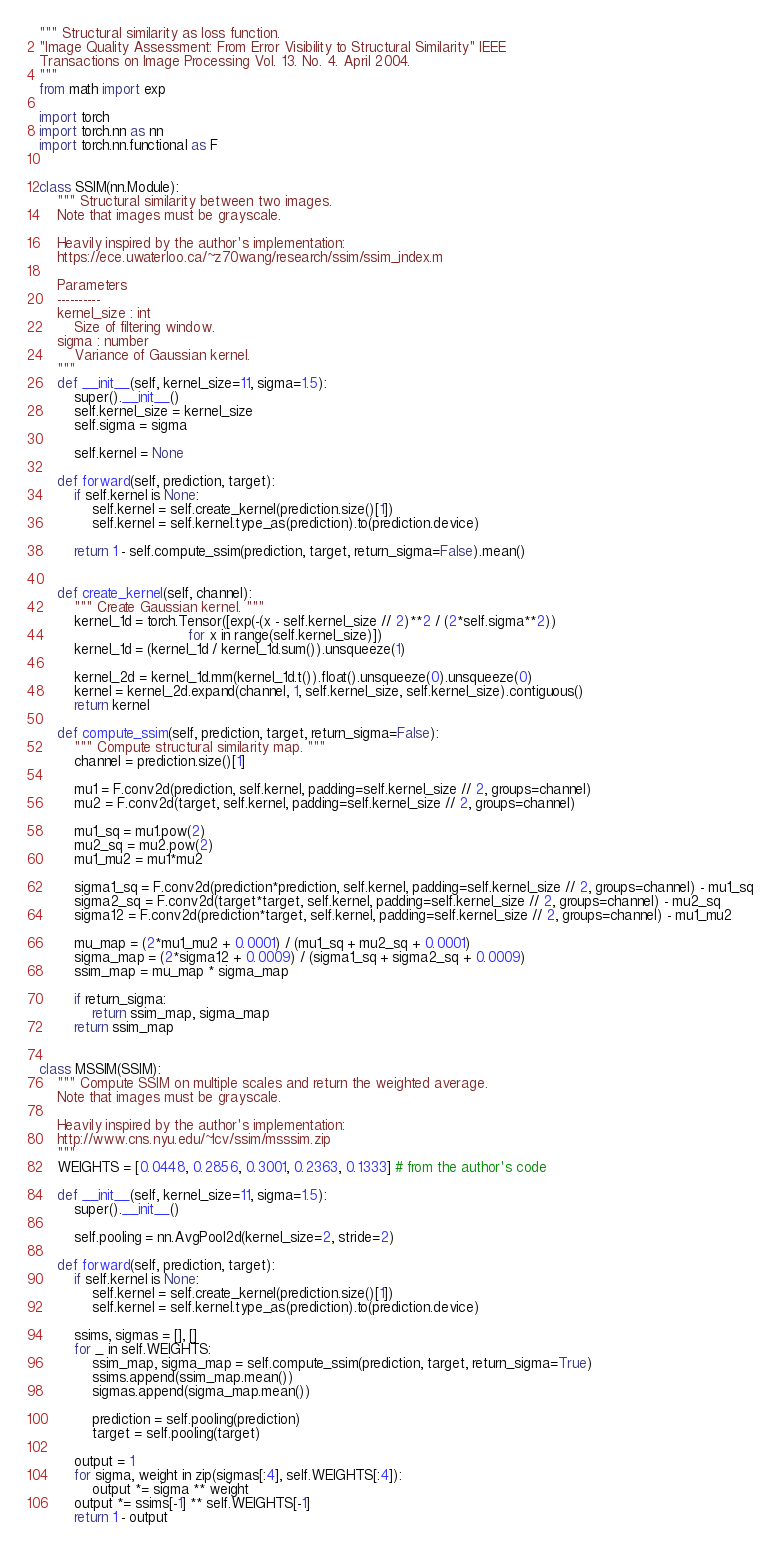Convert code to text. <code><loc_0><loc_0><loc_500><loc_500><_Python_>""" Structural similarity as loss function.
"Image Quality Assessment: From Error Visibility to Structural Similarity" IEEE
Transactions on Image Processing Vol. 13. No. 4. April 2004.
"""
from math import exp

import torch
import torch.nn as nn
import torch.nn.functional as F


class SSIM(nn.Module):
    """ Structural similarity between two images.
    Note that images must be grayscale.

    Heavily inspired by the author's implementation:
    https://ece.uwaterloo.ca/~z70wang/research/ssim/ssim_index.m

    Parameters
    ----------
    kernel_size : int
        Size of filtering window.
    sigma : number
        Variance of Gaussian kernel.
    """
    def __init__(self, kernel_size=11, sigma=1.5):
        super().__init__()
        self.kernel_size = kernel_size
        self.sigma = sigma

        self.kernel = None

    def forward(self, prediction, target):
        if self.kernel is None:
            self.kernel = self.create_kernel(prediction.size()[1])
            self.kernel = self.kernel.type_as(prediction).to(prediction.device)

        return 1 - self.compute_ssim(prediction, target, return_sigma=False).mean()


    def create_kernel(self, channel):
        """ Create Gaussian kernel. """
        kernel_1d = torch.Tensor([exp(-(x - self.kernel_size // 2)**2 / (2*self.sigma**2))
                                  for x in range(self.kernel_size)])
        kernel_1d = (kernel_1d / kernel_1d.sum()).unsqueeze(1)

        kernel_2d = kernel_1d.mm(kernel_1d.t()).float().unsqueeze(0).unsqueeze(0)
        kernel = kernel_2d.expand(channel, 1, self.kernel_size, self.kernel_size).contiguous()
        return kernel

    def compute_ssim(self, prediction, target, return_sigma=False):
        """ Compute structural similarity map. """
        channel = prediction.size()[1]

        mu1 = F.conv2d(prediction, self.kernel, padding=self.kernel_size // 2, groups=channel)
        mu2 = F.conv2d(target, self.kernel, padding=self.kernel_size // 2, groups=channel)

        mu1_sq = mu1.pow(2)
        mu2_sq = mu2.pow(2)
        mu1_mu2 = mu1*mu2

        sigma1_sq = F.conv2d(prediction*prediction, self.kernel, padding=self.kernel_size // 2, groups=channel) - mu1_sq
        sigma2_sq = F.conv2d(target*target, self.kernel, padding=self.kernel_size // 2, groups=channel) - mu2_sq
        sigma12 = F.conv2d(prediction*target, self.kernel, padding=self.kernel_size // 2, groups=channel) - mu1_mu2

        mu_map = (2*mu1_mu2 + 0.0001) / (mu1_sq + mu2_sq + 0.0001)
        sigma_map = (2*sigma12 + 0.0009) / (sigma1_sq + sigma2_sq + 0.0009)
        ssim_map = mu_map * sigma_map

        if return_sigma:
            return ssim_map, sigma_map
        return ssim_map


class MSSIM(SSIM):
    """ Compute SSIM on multiple scales and return the weighted average.
    Note that images must be grayscale.

    Heavily inspired by the author's implementation:
    http://www.cns.nyu.edu/~lcv/ssim/msssim.zip
    """
    WEIGHTS = [0.0448, 0.2856, 0.3001, 0.2363, 0.1333] # from the author's code

    def __init__(self, kernel_size=11, sigma=1.5):
        super().__init__()

        self.pooling = nn.AvgPool2d(kernel_size=2, stride=2)

    def forward(self, prediction, target):
        if self.kernel is None:
            self.kernel = self.create_kernel(prediction.size()[1])
            self.kernel = self.kernel.type_as(prediction).to(prediction.device)

        ssims, sigmas = [], []
        for _ in self.WEIGHTS:
            ssim_map, sigma_map = self.compute_ssim(prediction, target, return_sigma=True)
            ssims.append(ssim_map.mean())
            sigmas.append(sigma_map.mean())

            prediction = self.pooling(prediction)
            target = self.pooling(target)

        output = 1
        for sigma, weight in zip(sigmas[:4], self.WEIGHTS[:4]):
            output *= sigma ** weight
        output *= ssims[-1] ** self.WEIGHTS[-1]
        return 1 - output
</code> 